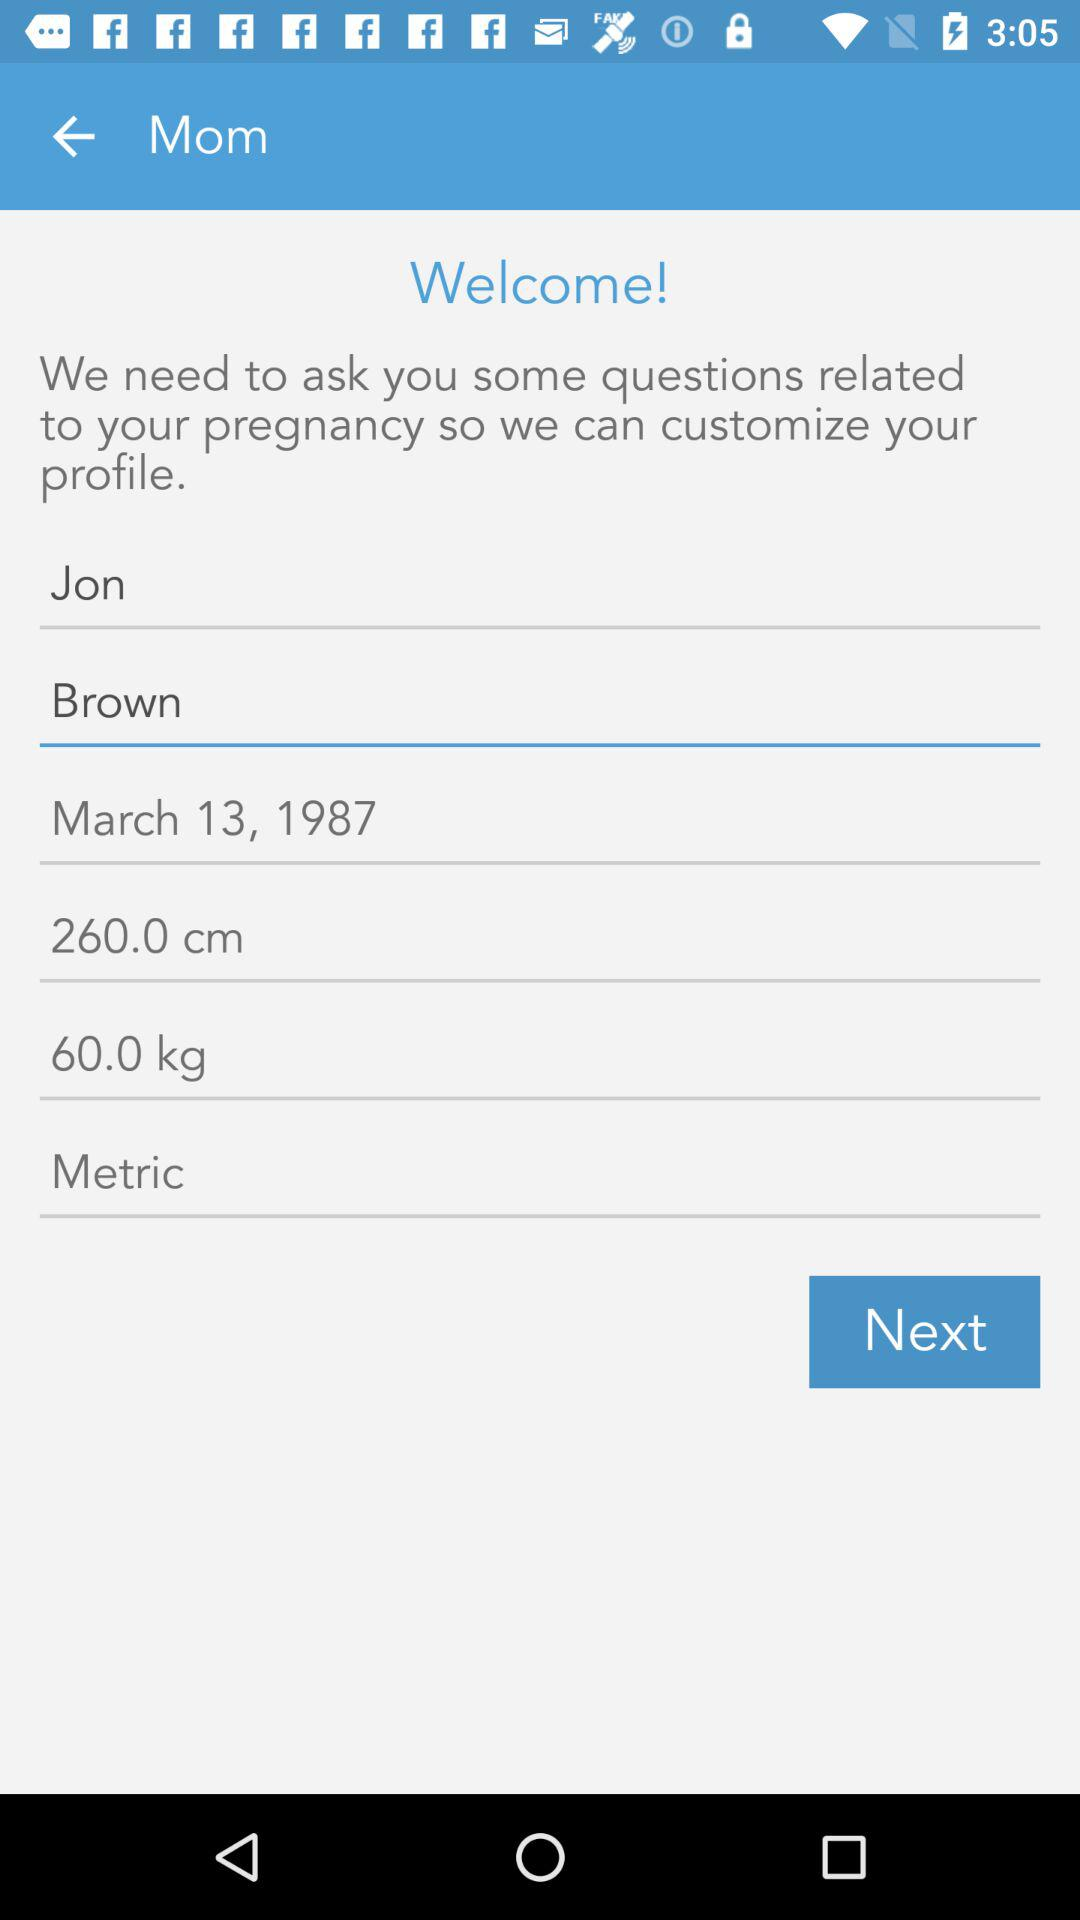How much does the user weigh?
Answer the question using a single word or phrase. 60.0 kg 